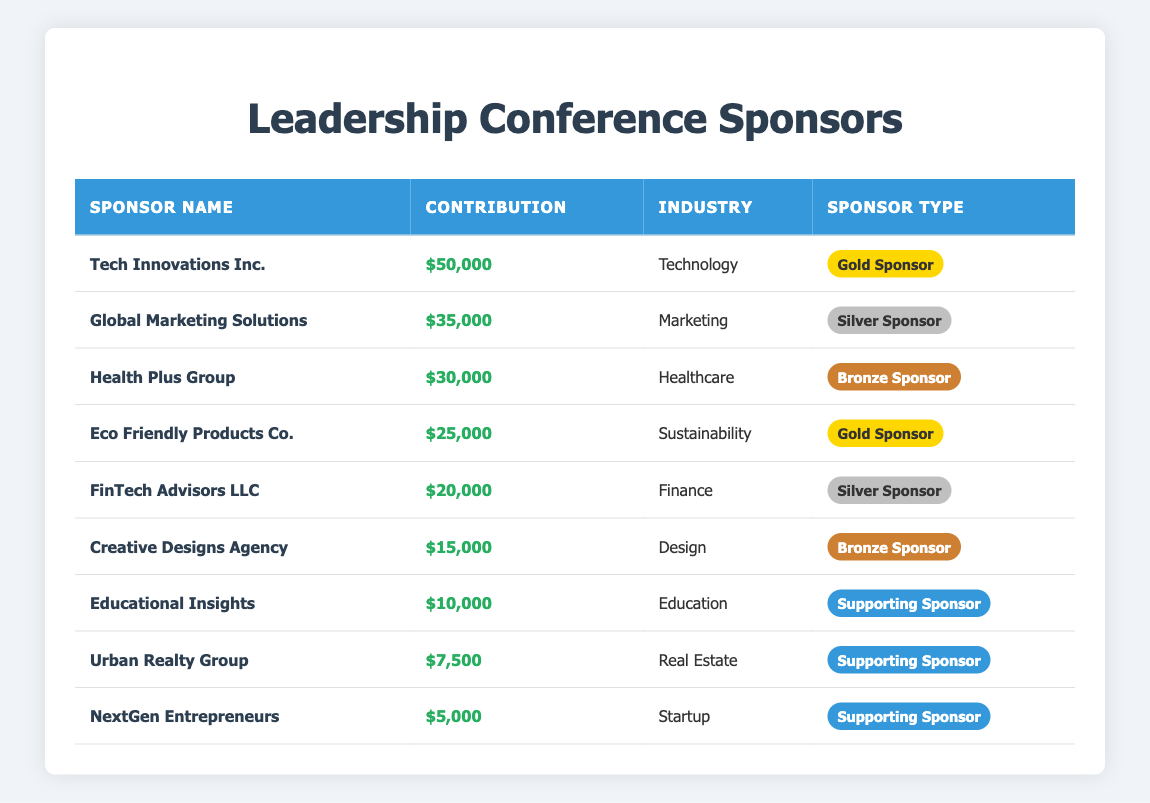What is the total contribution from all sponsors? To find the total contribution, sum all the contributions listed for each sponsor: 50000 + 35000 + 30000 + 25000 + 20000 + 15000 + 10000 + 7500 + 5000 = 200500.
Answer: 200500 Which sponsor has the highest contribution? The sponsor with the highest contribution is Tech Innovations Inc., which contributed $50000.
Answer: Tech Innovations Inc How many sponsors belong to the Technology industry? There is one sponsor in the Technology industry: Tech Innovations Inc.
Answer: 1 What is the average contribution of the sponsors? To find the average, divide the total contribution by the number of sponsors. Total contribution is 200500, and there are 9 sponsors. So, 200500 / 9 = 22277.78.
Answer: 22277.78 Is Eco Friendly Products Co. a Gold Sponsor? Yes, Eco Friendly Products Co. is categorized as a Gold Sponsor.
Answer: Yes What is the total contribution from Silver Sponsors? The Silver Sponsors are Global Marketing Solutions ($35000) and FinTech Advisors LLC ($20000). So, their total contribution is 35000 + 20000 = 55000.
Answer: 55000 How many sponsors have contributed at least $20,000? The sponsors with contributions of at least $20,000 are: Tech Innovations Inc. ($50000), Global Marketing Solutions ($35000), Health Plus Group ($30000), Eco Friendly Products Co. ($25000), and FinTech Advisors LLC ($20000). That's 5 sponsors.
Answer: 5 What percentage of the total contributions do Gold Sponsors represent? Total contributions from Gold Sponsors: Tech Innovations Inc. ($50000) + Eco Friendly Products Co. ($25000) = $75000. To find the percentage, (75000 / 200500) * 100 = 37.39%.
Answer: 37.39% How many sponsors contributed less than $10,000? Only one sponsor, NextGen Entrepreneurs, contributed less than $10,000 ($5000).
Answer: 1 Which industry has the lowest contribution total, and how much is it? The industry with the lowest contribution is Startup, represented by NextGen Entrepreneurs, which contributed $5000.
Answer: Startup, $5000 